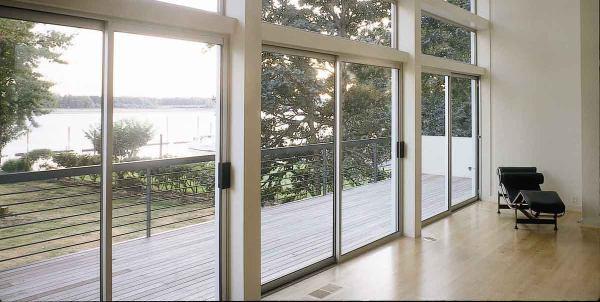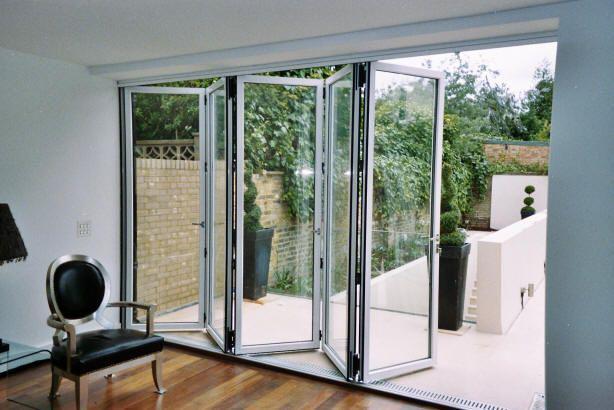The first image is the image on the left, the second image is the image on the right. Analyze the images presented: Is the assertion "There is at least one chair visible through the sliding glass doors." valid? Answer yes or no. No. The first image is the image on the left, the second image is the image on the right. Evaluate the accuracy of this statement regarding the images: "All the doors are closed.". Is it true? Answer yes or no. No. 